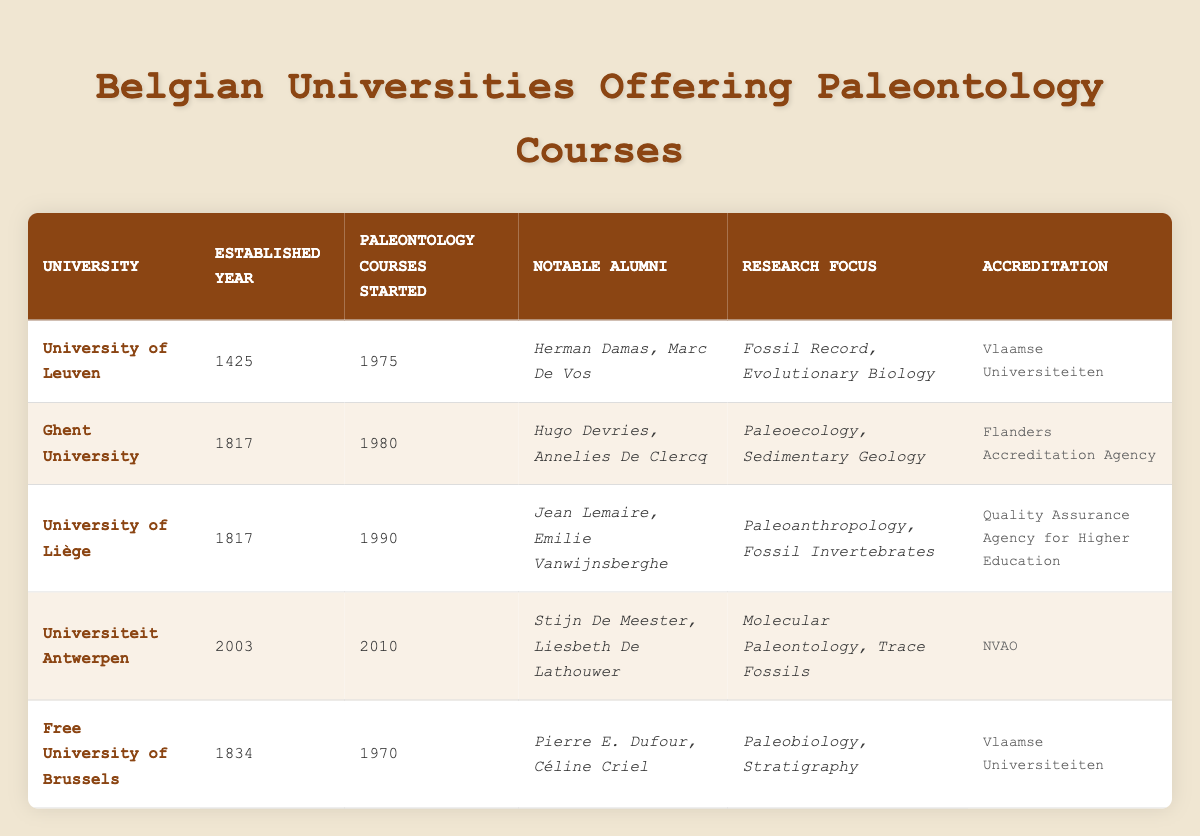What university was established first among the listed ones? The table lists the established years for each university. The University of Leuven is established in 1425, which is earlier than all others listed (Ghent University and the University of Liège in 1817, Free University of Brussels in 1834, and Universiteit Antwerpen in 2003).
Answer: University of Leuven Which university started offering paleontology courses the earliest? According to the table, the Free University of Brussels began its paleontology courses in 1970, which is earlier than the University of Leuven's start in 1975, Ghent University in 1980, and the University of Liège in 1990. The latest was Universiteit Antwerpen in 2010.
Answer: Free University of Brussels How many universities have been established after the year 2000? The table shows five universities, with only Universiteit Antwerpen established in 2003. Therefore, it is the only one from this list established after 2000.
Answer: 1 Is the accreditation of the University of Liège provided by the same agency as Ghent University? The table indicates that the University of Liège is accredited by the Quality Assurance Agency for Higher Education, while Ghent University’s accreditation comes from the Flanders Accreditation Agency, showing that they are different.
Answer: No What is the average established year of the universities in the table? The established years are: 1425 (University of Leuven), 1817 (Ghent University), 1817 (University of Liège), 1834 (Free University of Brussels), and 2003 (Universiteit Antwerpen). First, sum the years: 1425 + 1817 + 1817 + 1834 + 2003 = 9705. Then divide this by the number of universities (5): 9705 / 5 = 1941.
Answer: 1941 Which university has alumni that focus on "Paleoecology"? The notable alumni of Ghent University are Hugo Devries and Annelies De Clercq, as their research focus is specifically mentioned as Paleoecology.
Answer: Ghent University Did any of the universities start offering paleontology courses in the 1990s? The table shows that the University of Liège began offering paleontology courses in 1990, confirming that at least one university did so in that decade.
Answer: Yes What is the research focus of Universiteit Antwerpen? From the table, Universiteit Antwerpen's research focuses are Molecular Paleontology and Trace Fossils, as listed in their associated research focus column.
Answer: Molecular Paleontology, Trace Fossils 